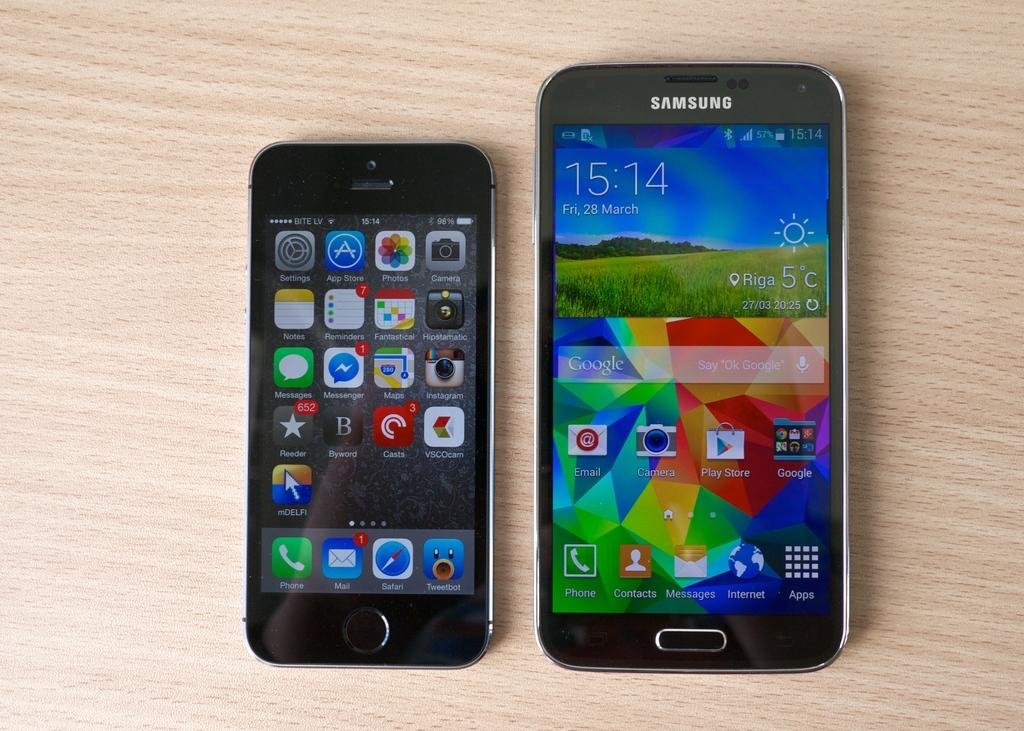<image>
Write a terse but informative summary of the picture. A Samsung phone sits next to an iPhone on a table. 